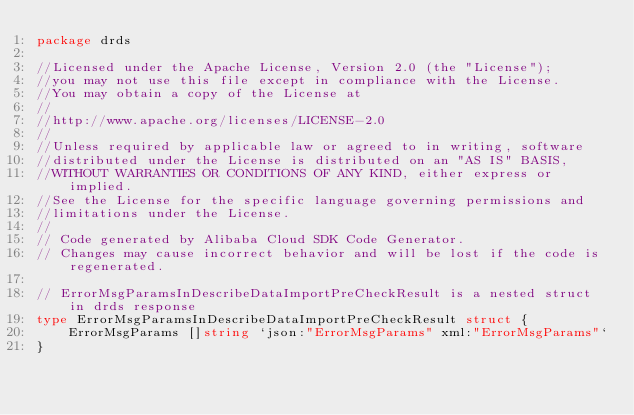Convert code to text. <code><loc_0><loc_0><loc_500><loc_500><_Go_>package drds

//Licensed under the Apache License, Version 2.0 (the "License");
//you may not use this file except in compliance with the License.
//You may obtain a copy of the License at
//
//http://www.apache.org/licenses/LICENSE-2.0
//
//Unless required by applicable law or agreed to in writing, software
//distributed under the License is distributed on an "AS IS" BASIS,
//WITHOUT WARRANTIES OR CONDITIONS OF ANY KIND, either express or implied.
//See the License for the specific language governing permissions and
//limitations under the License.
//
// Code generated by Alibaba Cloud SDK Code Generator.
// Changes may cause incorrect behavior and will be lost if the code is regenerated.

// ErrorMsgParamsInDescribeDataImportPreCheckResult is a nested struct in drds response
type ErrorMsgParamsInDescribeDataImportPreCheckResult struct {
	ErrorMsgParams []string `json:"ErrorMsgParams" xml:"ErrorMsgParams"`
}
</code> 